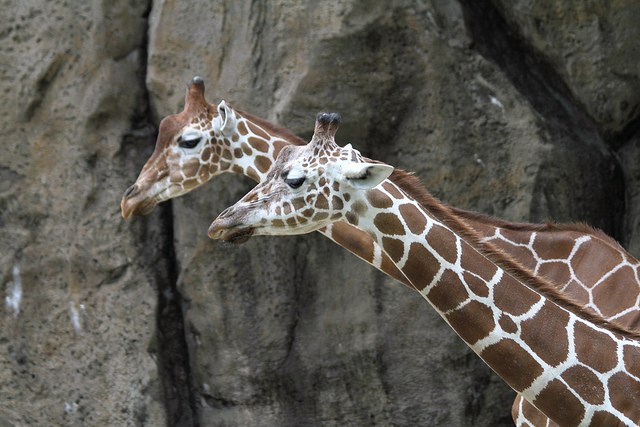<image>Are the giraffes male or female? I don't know if the giraffes are male or female. It could be either. Are the giraffes male or female? I am not sure if the giraffes are male or female. It can be seen both male and female. 